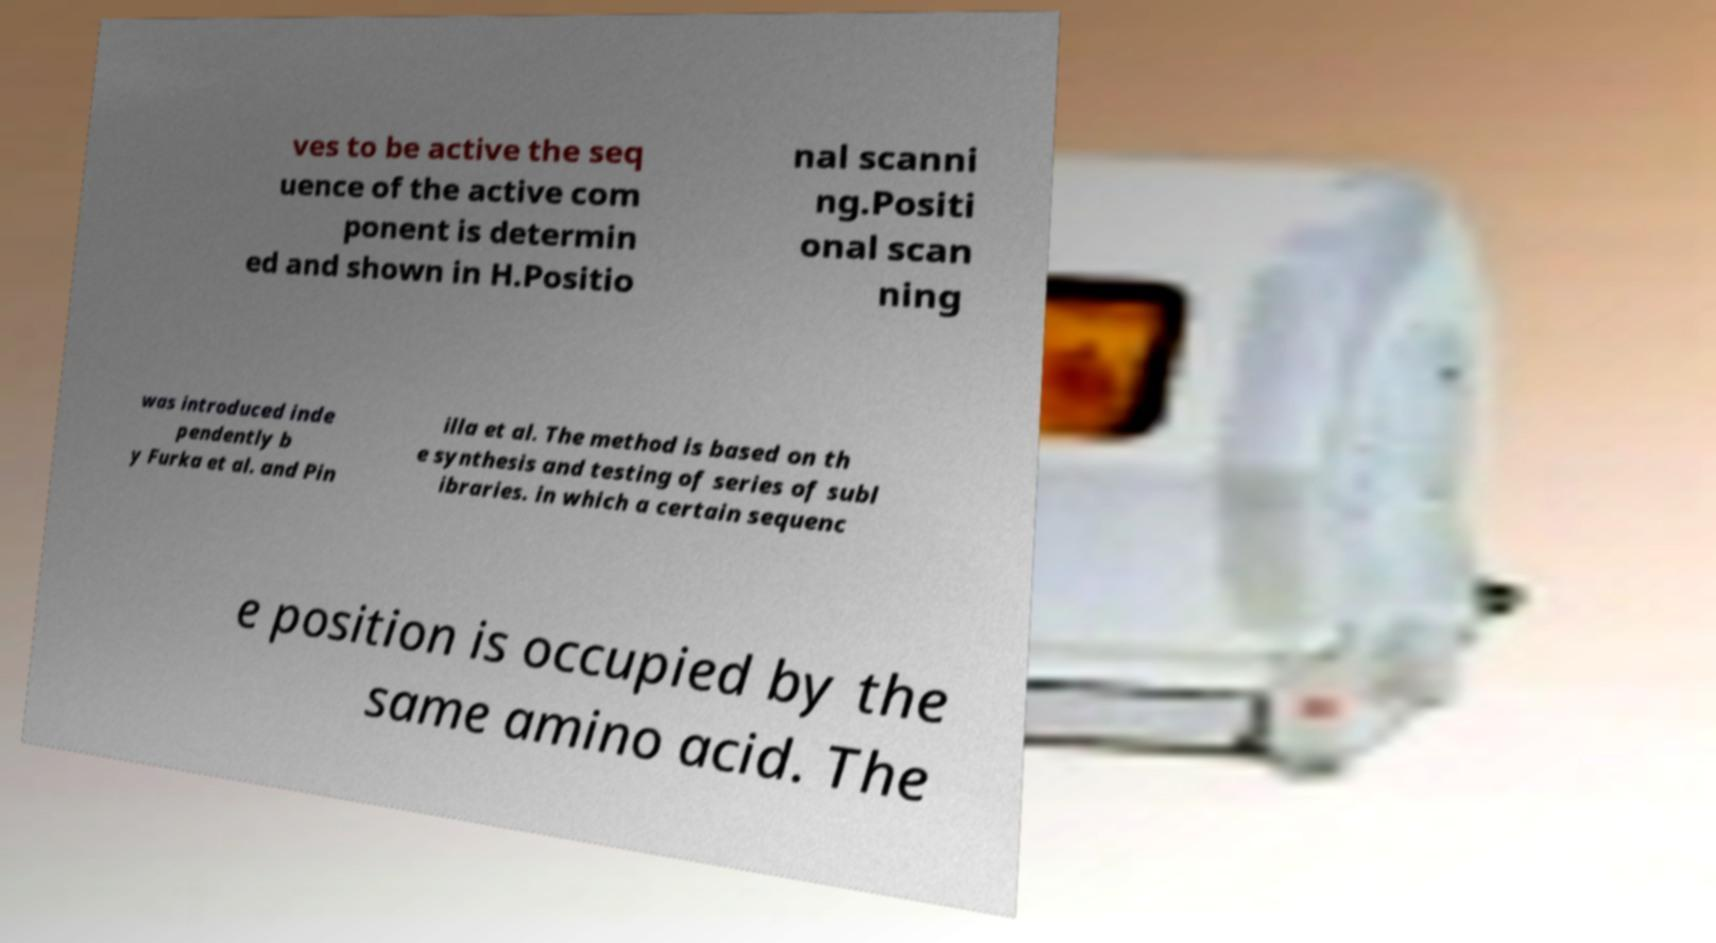I need the written content from this picture converted into text. Can you do that? ves to be active the seq uence of the active com ponent is determin ed and shown in H.Positio nal scanni ng.Positi onal scan ning was introduced inde pendently b y Furka et al. and Pin illa et al. The method is based on th e synthesis and testing of series of subl ibraries. in which a certain sequenc e position is occupied by the same amino acid. The 